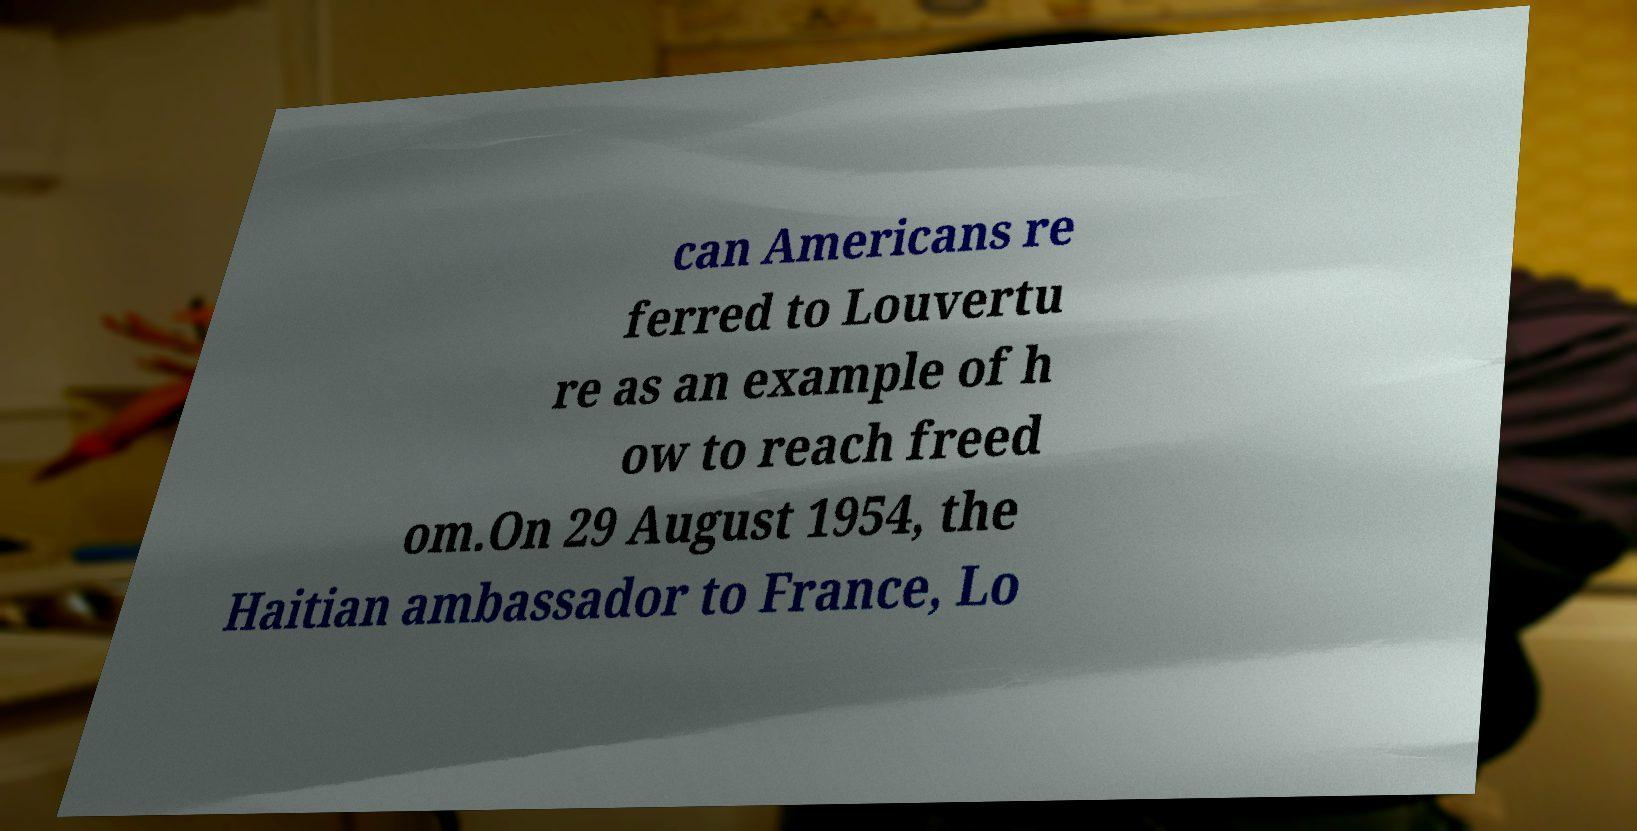Could you assist in decoding the text presented in this image and type it out clearly? can Americans re ferred to Louvertu re as an example of h ow to reach freed om.On 29 August 1954, the Haitian ambassador to France, Lo 